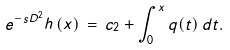Convert formula to latex. <formula><loc_0><loc_0><loc_500><loc_500>e ^ { - s D ^ { 2 } } h \, ( x ) \, = \, c _ { 2 } + \int _ { 0 } ^ { x } q ( t ) \, d t .</formula> 